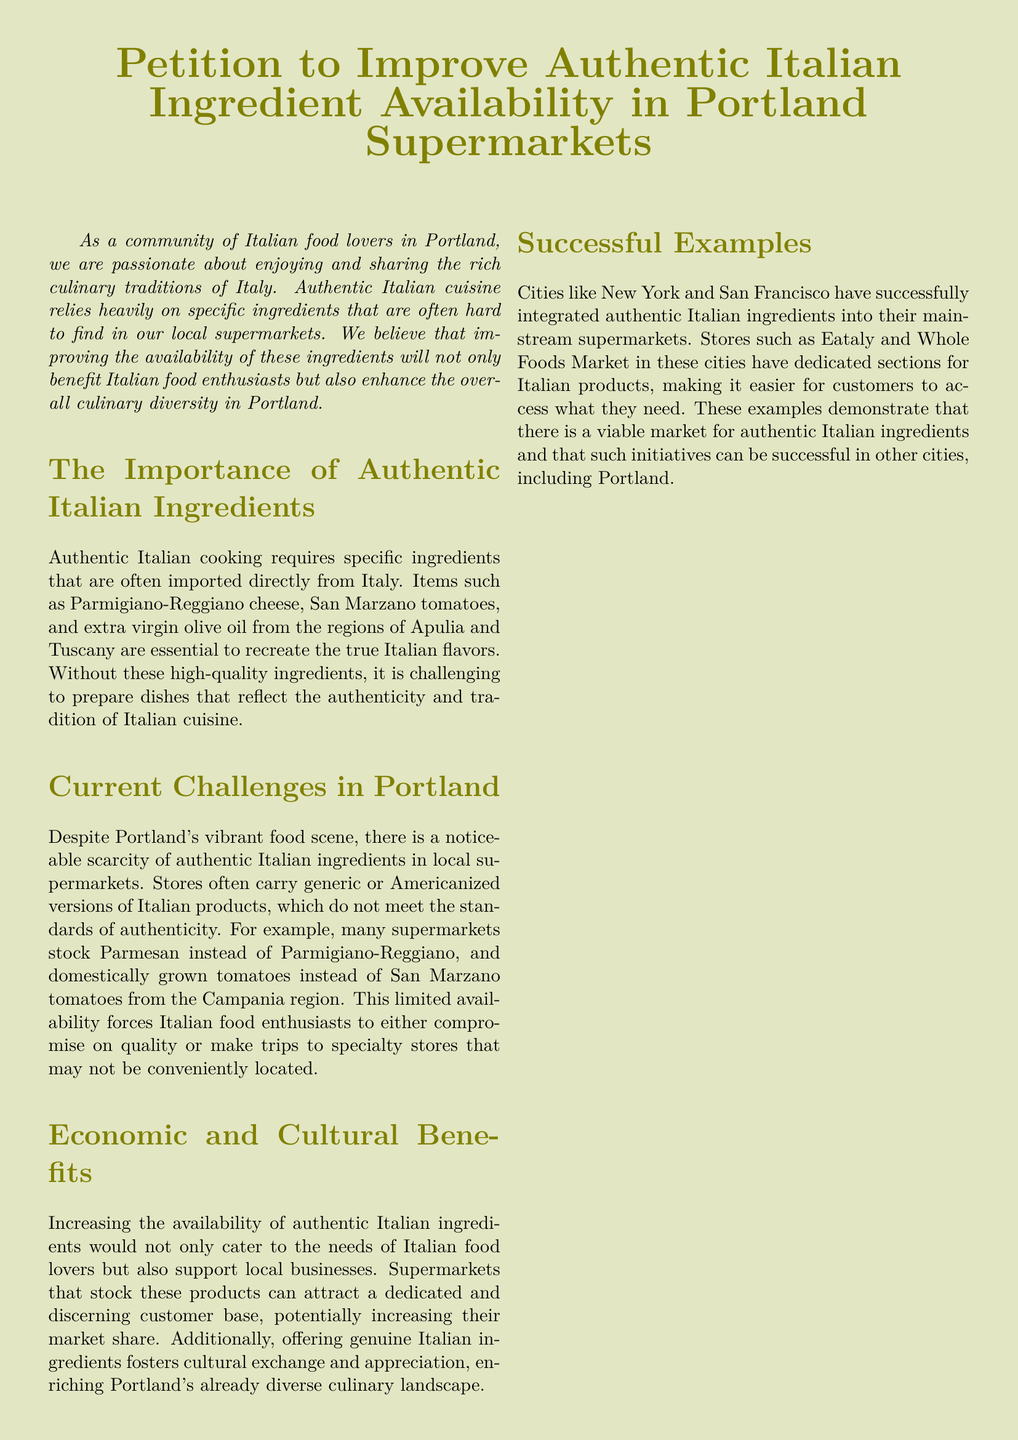what is the title of the petition? The title is stated prominently at the beginning of the document, which focuses on improving ingredient availability.
Answer: Petition to Improve Authentic Italian Ingredient Availability in Portland Supermarkets who are the intended beneficiaries of the petition? The document discusses the community of Italian food lovers in Portland as its primary audience.
Answer: Italian food lovers name one specific ingredient mentioned that is difficult to find in Portland. The document lists specific ingredients that are often hard to find, highlighting one as particularly important.
Answer: Parmigiano-Reggiano cheese what are two local supermarkets mentioned in the petition? The document refers to specific local supermarkets as examples for improving ingredient availability.
Answer: New Seasons Market, Fred Meyer what city is referenced as having successfully integrated authentic Italian ingredients? The document mentions successful examples of integrating Italian ingredients in different cities.
Answer: New York how many signatures are provided for collection on the petition? The document includes a table for signatures; the number of rows indicates the quantity.
Answer: 5 what is the contact email provided in the petition? The document lists a contact email for further inquiries related to the petition.
Answer: info@italianfoodportland.org what is one economic benefit highlighted in the document? The petition outlines how stocking authentic ingredients can support local businesses and attract customers.
Answer: Support local businesses 